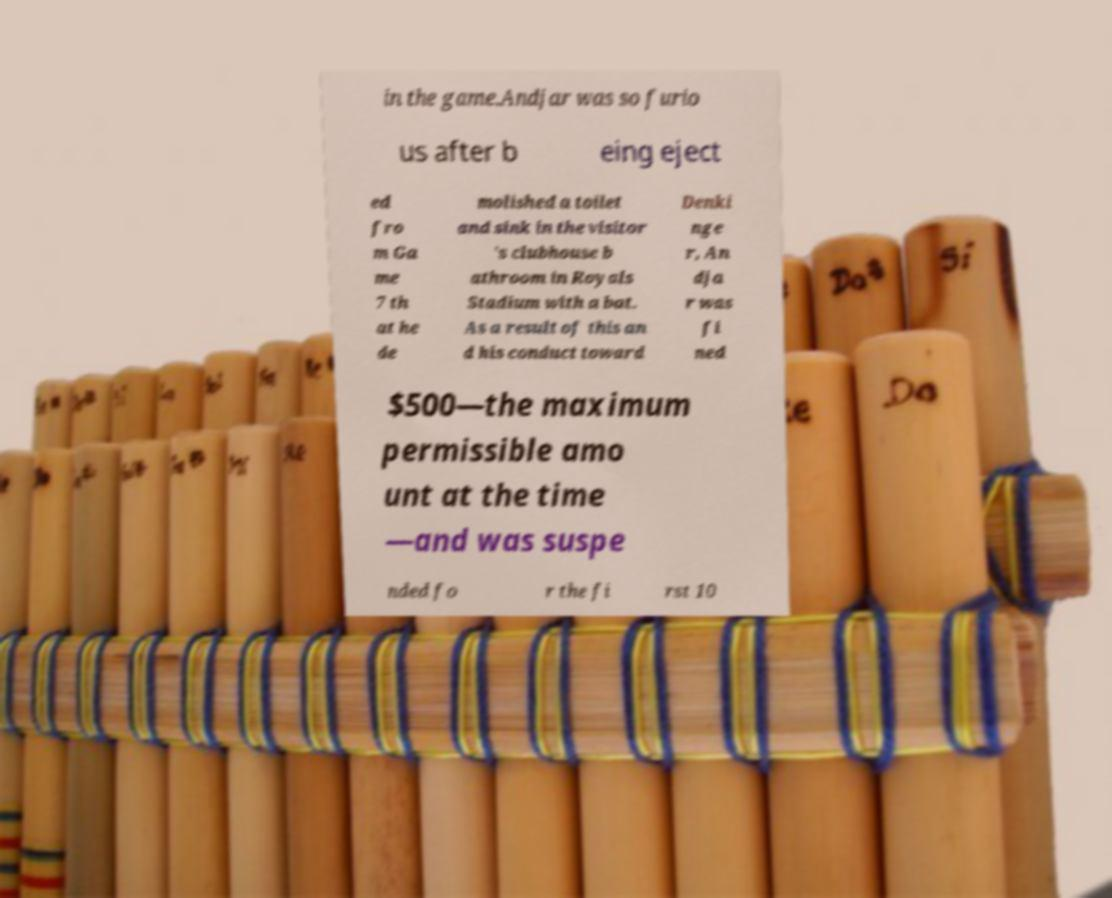There's text embedded in this image that I need extracted. Can you transcribe it verbatim? in the game.Andjar was so furio us after b eing eject ed fro m Ga me 7 th at he de molished a toilet and sink in the visitor 's clubhouse b athroom in Royals Stadium with a bat. As a result of this an d his conduct toward Denki nge r, An dja r was fi ned $500—the maximum permissible amo unt at the time —and was suspe nded fo r the fi rst 10 